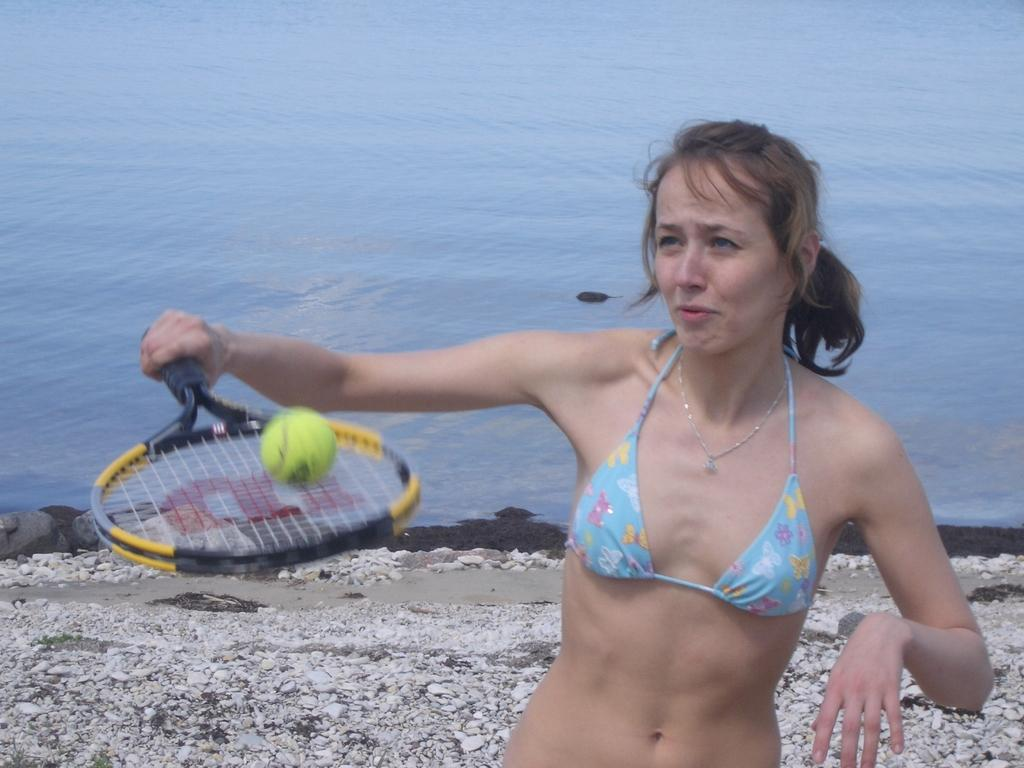Who is present in the image? There is a woman in the image. What is the woman doing in the image? The woman is standing and holding a bat in her hand. What can be seen behind the woman? There is water visible behind the woman. How many chairs are visible in the image? There are no chairs present in the image. 